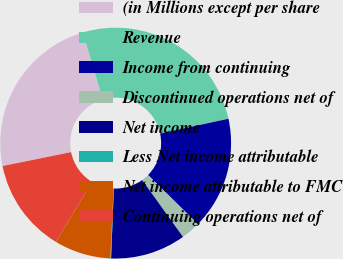Convert chart to OTSL. <chart><loc_0><loc_0><loc_500><loc_500><pie_chart><fcel>(in Millions except per share<fcel>Revenue<fcel>Income from continuing<fcel>Discontinued operations net of<fcel>Net income<fcel>Less Net income attributable<fcel>Net income attributable to FMC<fcel>Continuing operations net of<nl><fcel>23.59%<fcel>26.2%<fcel>15.76%<fcel>2.71%<fcel>10.54%<fcel>0.1%<fcel>7.93%<fcel>13.15%<nl></chart> 